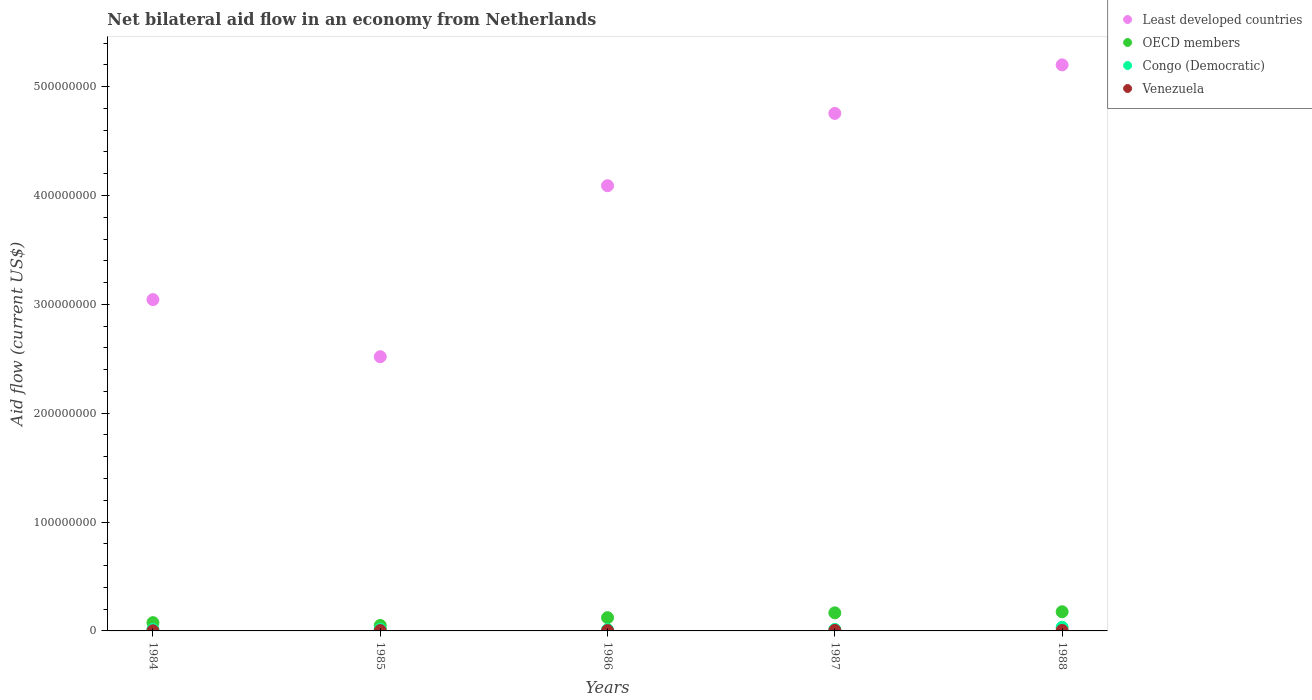How many different coloured dotlines are there?
Offer a very short reply. 4. What is the net bilateral aid flow in OECD members in 1988?
Provide a short and direct response. 1.76e+07. Across all years, what is the maximum net bilateral aid flow in OECD members?
Provide a short and direct response. 1.76e+07. In which year was the net bilateral aid flow in Venezuela minimum?
Your response must be concise. 1984. What is the total net bilateral aid flow in Least developed countries in the graph?
Your answer should be compact. 1.96e+09. What is the difference between the net bilateral aid flow in Venezuela in 1987 and that in 1988?
Keep it short and to the point. 8.00e+04. What is the difference between the net bilateral aid flow in OECD members in 1986 and the net bilateral aid flow in Congo (Democratic) in 1987?
Offer a very short reply. 1.08e+07. What is the average net bilateral aid flow in Congo (Democratic) per year?
Offer a very short reply. 1.81e+06. In the year 1987, what is the difference between the net bilateral aid flow in Least developed countries and net bilateral aid flow in Venezuela?
Give a very brief answer. 4.75e+08. What is the ratio of the net bilateral aid flow in Congo (Democratic) in 1986 to that in 1988?
Your answer should be very brief. 0.36. Is the difference between the net bilateral aid flow in Least developed countries in 1985 and 1986 greater than the difference between the net bilateral aid flow in Venezuela in 1985 and 1986?
Offer a terse response. No. What is the difference between the highest and the lowest net bilateral aid flow in Congo (Democratic)?
Your answer should be compact. 2.16e+06. In how many years, is the net bilateral aid flow in Least developed countries greater than the average net bilateral aid flow in Least developed countries taken over all years?
Make the answer very short. 3. Is the sum of the net bilateral aid flow in OECD members in 1985 and 1986 greater than the maximum net bilateral aid flow in Least developed countries across all years?
Offer a terse response. No. Is it the case that in every year, the sum of the net bilateral aid flow in Least developed countries and net bilateral aid flow in Congo (Democratic)  is greater than the sum of net bilateral aid flow in OECD members and net bilateral aid flow in Venezuela?
Your response must be concise. Yes. Is it the case that in every year, the sum of the net bilateral aid flow in Least developed countries and net bilateral aid flow in OECD members  is greater than the net bilateral aid flow in Congo (Democratic)?
Make the answer very short. Yes. Does the net bilateral aid flow in Least developed countries monotonically increase over the years?
Your answer should be compact. No. How many years are there in the graph?
Your answer should be compact. 5. Does the graph contain grids?
Make the answer very short. No. What is the title of the graph?
Make the answer very short. Net bilateral aid flow in an economy from Netherlands. Does "Madagascar" appear as one of the legend labels in the graph?
Provide a succinct answer. No. What is the label or title of the Y-axis?
Offer a terse response. Aid flow (current US$). What is the Aid flow (current US$) of Least developed countries in 1984?
Your answer should be very brief. 3.04e+08. What is the Aid flow (current US$) in OECD members in 1984?
Provide a succinct answer. 7.60e+06. What is the Aid flow (current US$) in Congo (Democratic) in 1984?
Your answer should be very brief. 1.43e+06. What is the Aid flow (current US$) in Least developed countries in 1985?
Give a very brief answer. 2.52e+08. What is the Aid flow (current US$) of OECD members in 1985?
Offer a very short reply. 5.03e+06. What is the Aid flow (current US$) in Congo (Democratic) in 1985?
Keep it short and to the point. 1.69e+06. What is the Aid flow (current US$) of Venezuela in 1985?
Provide a succinct answer. 3.20e+05. What is the Aid flow (current US$) of Least developed countries in 1986?
Give a very brief answer. 4.09e+08. What is the Aid flow (current US$) of OECD members in 1986?
Give a very brief answer. 1.22e+07. What is the Aid flow (current US$) in Congo (Democratic) in 1986?
Your answer should be very brief. 1.19e+06. What is the Aid flow (current US$) of Least developed countries in 1987?
Your answer should be very brief. 4.75e+08. What is the Aid flow (current US$) in OECD members in 1987?
Offer a very short reply. 1.66e+07. What is the Aid flow (current US$) in Congo (Democratic) in 1987?
Provide a short and direct response. 1.37e+06. What is the Aid flow (current US$) in Least developed countries in 1988?
Ensure brevity in your answer.  5.20e+08. What is the Aid flow (current US$) of OECD members in 1988?
Give a very brief answer. 1.76e+07. What is the Aid flow (current US$) in Congo (Democratic) in 1988?
Ensure brevity in your answer.  3.35e+06. Across all years, what is the maximum Aid flow (current US$) of Least developed countries?
Offer a very short reply. 5.20e+08. Across all years, what is the maximum Aid flow (current US$) in OECD members?
Give a very brief answer. 1.76e+07. Across all years, what is the maximum Aid flow (current US$) in Congo (Democratic)?
Offer a very short reply. 3.35e+06. Across all years, what is the minimum Aid flow (current US$) of Least developed countries?
Give a very brief answer. 2.52e+08. Across all years, what is the minimum Aid flow (current US$) in OECD members?
Your response must be concise. 5.03e+06. Across all years, what is the minimum Aid flow (current US$) of Congo (Democratic)?
Offer a very short reply. 1.19e+06. Across all years, what is the minimum Aid flow (current US$) in Venezuela?
Keep it short and to the point. 1.10e+05. What is the total Aid flow (current US$) of Least developed countries in the graph?
Your answer should be very brief. 1.96e+09. What is the total Aid flow (current US$) in OECD members in the graph?
Your response must be concise. 5.90e+07. What is the total Aid flow (current US$) of Congo (Democratic) in the graph?
Your answer should be compact. 9.03e+06. What is the total Aid flow (current US$) in Venezuela in the graph?
Make the answer very short. 1.61e+06. What is the difference between the Aid flow (current US$) in Least developed countries in 1984 and that in 1985?
Ensure brevity in your answer.  5.25e+07. What is the difference between the Aid flow (current US$) in OECD members in 1984 and that in 1985?
Ensure brevity in your answer.  2.57e+06. What is the difference between the Aid flow (current US$) of Least developed countries in 1984 and that in 1986?
Give a very brief answer. -1.05e+08. What is the difference between the Aid flow (current US$) in OECD members in 1984 and that in 1986?
Provide a short and direct response. -4.58e+06. What is the difference between the Aid flow (current US$) in Congo (Democratic) in 1984 and that in 1986?
Give a very brief answer. 2.40e+05. What is the difference between the Aid flow (current US$) in Least developed countries in 1984 and that in 1987?
Offer a terse response. -1.71e+08. What is the difference between the Aid flow (current US$) of OECD members in 1984 and that in 1987?
Your response must be concise. -9.02e+06. What is the difference between the Aid flow (current US$) of Venezuela in 1984 and that in 1987?
Give a very brief answer. -3.60e+05. What is the difference between the Aid flow (current US$) in Least developed countries in 1984 and that in 1988?
Offer a terse response. -2.16e+08. What is the difference between the Aid flow (current US$) in OECD members in 1984 and that in 1988?
Your answer should be very brief. -1.00e+07. What is the difference between the Aid flow (current US$) of Congo (Democratic) in 1984 and that in 1988?
Provide a short and direct response. -1.92e+06. What is the difference between the Aid flow (current US$) in Venezuela in 1984 and that in 1988?
Ensure brevity in your answer.  -2.80e+05. What is the difference between the Aid flow (current US$) of Least developed countries in 1985 and that in 1986?
Keep it short and to the point. -1.57e+08. What is the difference between the Aid flow (current US$) of OECD members in 1985 and that in 1986?
Ensure brevity in your answer.  -7.15e+06. What is the difference between the Aid flow (current US$) of Least developed countries in 1985 and that in 1987?
Offer a very short reply. -2.24e+08. What is the difference between the Aid flow (current US$) of OECD members in 1985 and that in 1987?
Ensure brevity in your answer.  -1.16e+07. What is the difference between the Aid flow (current US$) of Congo (Democratic) in 1985 and that in 1987?
Offer a terse response. 3.20e+05. What is the difference between the Aid flow (current US$) in Venezuela in 1985 and that in 1987?
Your response must be concise. -1.50e+05. What is the difference between the Aid flow (current US$) of Least developed countries in 1985 and that in 1988?
Your answer should be compact. -2.68e+08. What is the difference between the Aid flow (current US$) in OECD members in 1985 and that in 1988?
Keep it short and to the point. -1.26e+07. What is the difference between the Aid flow (current US$) of Congo (Democratic) in 1985 and that in 1988?
Your answer should be very brief. -1.66e+06. What is the difference between the Aid flow (current US$) of Venezuela in 1985 and that in 1988?
Offer a very short reply. -7.00e+04. What is the difference between the Aid flow (current US$) in Least developed countries in 1986 and that in 1987?
Your response must be concise. -6.64e+07. What is the difference between the Aid flow (current US$) in OECD members in 1986 and that in 1987?
Provide a short and direct response. -4.44e+06. What is the difference between the Aid flow (current US$) of Congo (Democratic) in 1986 and that in 1987?
Your answer should be compact. -1.80e+05. What is the difference between the Aid flow (current US$) in Venezuela in 1986 and that in 1987?
Provide a short and direct response. -1.50e+05. What is the difference between the Aid flow (current US$) in Least developed countries in 1986 and that in 1988?
Provide a short and direct response. -1.11e+08. What is the difference between the Aid flow (current US$) in OECD members in 1986 and that in 1988?
Ensure brevity in your answer.  -5.43e+06. What is the difference between the Aid flow (current US$) in Congo (Democratic) in 1986 and that in 1988?
Your answer should be compact. -2.16e+06. What is the difference between the Aid flow (current US$) in Venezuela in 1986 and that in 1988?
Keep it short and to the point. -7.00e+04. What is the difference between the Aid flow (current US$) in Least developed countries in 1987 and that in 1988?
Offer a terse response. -4.46e+07. What is the difference between the Aid flow (current US$) in OECD members in 1987 and that in 1988?
Ensure brevity in your answer.  -9.90e+05. What is the difference between the Aid flow (current US$) of Congo (Democratic) in 1987 and that in 1988?
Your answer should be very brief. -1.98e+06. What is the difference between the Aid flow (current US$) of Least developed countries in 1984 and the Aid flow (current US$) of OECD members in 1985?
Make the answer very short. 2.99e+08. What is the difference between the Aid flow (current US$) of Least developed countries in 1984 and the Aid flow (current US$) of Congo (Democratic) in 1985?
Provide a succinct answer. 3.03e+08. What is the difference between the Aid flow (current US$) of Least developed countries in 1984 and the Aid flow (current US$) of Venezuela in 1985?
Offer a very short reply. 3.04e+08. What is the difference between the Aid flow (current US$) in OECD members in 1984 and the Aid flow (current US$) in Congo (Democratic) in 1985?
Your answer should be compact. 5.91e+06. What is the difference between the Aid flow (current US$) of OECD members in 1984 and the Aid flow (current US$) of Venezuela in 1985?
Your response must be concise. 7.28e+06. What is the difference between the Aid flow (current US$) in Congo (Democratic) in 1984 and the Aid flow (current US$) in Venezuela in 1985?
Keep it short and to the point. 1.11e+06. What is the difference between the Aid flow (current US$) in Least developed countries in 1984 and the Aid flow (current US$) in OECD members in 1986?
Your response must be concise. 2.92e+08. What is the difference between the Aid flow (current US$) in Least developed countries in 1984 and the Aid flow (current US$) in Congo (Democratic) in 1986?
Make the answer very short. 3.03e+08. What is the difference between the Aid flow (current US$) of Least developed countries in 1984 and the Aid flow (current US$) of Venezuela in 1986?
Offer a terse response. 3.04e+08. What is the difference between the Aid flow (current US$) in OECD members in 1984 and the Aid flow (current US$) in Congo (Democratic) in 1986?
Provide a succinct answer. 6.41e+06. What is the difference between the Aid flow (current US$) in OECD members in 1984 and the Aid flow (current US$) in Venezuela in 1986?
Offer a very short reply. 7.28e+06. What is the difference between the Aid flow (current US$) in Congo (Democratic) in 1984 and the Aid flow (current US$) in Venezuela in 1986?
Provide a short and direct response. 1.11e+06. What is the difference between the Aid flow (current US$) of Least developed countries in 1984 and the Aid flow (current US$) of OECD members in 1987?
Give a very brief answer. 2.88e+08. What is the difference between the Aid flow (current US$) of Least developed countries in 1984 and the Aid flow (current US$) of Congo (Democratic) in 1987?
Offer a very short reply. 3.03e+08. What is the difference between the Aid flow (current US$) of Least developed countries in 1984 and the Aid flow (current US$) of Venezuela in 1987?
Provide a succinct answer. 3.04e+08. What is the difference between the Aid flow (current US$) in OECD members in 1984 and the Aid flow (current US$) in Congo (Democratic) in 1987?
Offer a very short reply. 6.23e+06. What is the difference between the Aid flow (current US$) of OECD members in 1984 and the Aid flow (current US$) of Venezuela in 1987?
Your response must be concise. 7.13e+06. What is the difference between the Aid flow (current US$) in Congo (Democratic) in 1984 and the Aid flow (current US$) in Venezuela in 1987?
Keep it short and to the point. 9.60e+05. What is the difference between the Aid flow (current US$) in Least developed countries in 1984 and the Aid flow (current US$) in OECD members in 1988?
Provide a succinct answer. 2.87e+08. What is the difference between the Aid flow (current US$) of Least developed countries in 1984 and the Aid flow (current US$) of Congo (Democratic) in 1988?
Make the answer very short. 3.01e+08. What is the difference between the Aid flow (current US$) of Least developed countries in 1984 and the Aid flow (current US$) of Venezuela in 1988?
Offer a terse response. 3.04e+08. What is the difference between the Aid flow (current US$) of OECD members in 1984 and the Aid flow (current US$) of Congo (Democratic) in 1988?
Ensure brevity in your answer.  4.25e+06. What is the difference between the Aid flow (current US$) of OECD members in 1984 and the Aid flow (current US$) of Venezuela in 1988?
Provide a short and direct response. 7.21e+06. What is the difference between the Aid flow (current US$) in Congo (Democratic) in 1984 and the Aid flow (current US$) in Venezuela in 1988?
Offer a terse response. 1.04e+06. What is the difference between the Aid flow (current US$) of Least developed countries in 1985 and the Aid flow (current US$) of OECD members in 1986?
Your answer should be compact. 2.40e+08. What is the difference between the Aid flow (current US$) in Least developed countries in 1985 and the Aid flow (current US$) in Congo (Democratic) in 1986?
Ensure brevity in your answer.  2.51e+08. What is the difference between the Aid flow (current US$) of Least developed countries in 1985 and the Aid flow (current US$) of Venezuela in 1986?
Keep it short and to the point. 2.52e+08. What is the difference between the Aid flow (current US$) of OECD members in 1985 and the Aid flow (current US$) of Congo (Democratic) in 1986?
Your response must be concise. 3.84e+06. What is the difference between the Aid flow (current US$) in OECD members in 1985 and the Aid flow (current US$) in Venezuela in 1986?
Ensure brevity in your answer.  4.71e+06. What is the difference between the Aid flow (current US$) in Congo (Democratic) in 1985 and the Aid flow (current US$) in Venezuela in 1986?
Offer a very short reply. 1.37e+06. What is the difference between the Aid flow (current US$) of Least developed countries in 1985 and the Aid flow (current US$) of OECD members in 1987?
Your response must be concise. 2.35e+08. What is the difference between the Aid flow (current US$) of Least developed countries in 1985 and the Aid flow (current US$) of Congo (Democratic) in 1987?
Provide a short and direct response. 2.51e+08. What is the difference between the Aid flow (current US$) of Least developed countries in 1985 and the Aid flow (current US$) of Venezuela in 1987?
Keep it short and to the point. 2.51e+08. What is the difference between the Aid flow (current US$) in OECD members in 1985 and the Aid flow (current US$) in Congo (Democratic) in 1987?
Ensure brevity in your answer.  3.66e+06. What is the difference between the Aid flow (current US$) of OECD members in 1985 and the Aid flow (current US$) of Venezuela in 1987?
Provide a short and direct response. 4.56e+06. What is the difference between the Aid flow (current US$) in Congo (Democratic) in 1985 and the Aid flow (current US$) in Venezuela in 1987?
Provide a short and direct response. 1.22e+06. What is the difference between the Aid flow (current US$) of Least developed countries in 1985 and the Aid flow (current US$) of OECD members in 1988?
Keep it short and to the point. 2.34e+08. What is the difference between the Aid flow (current US$) in Least developed countries in 1985 and the Aid flow (current US$) in Congo (Democratic) in 1988?
Your answer should be very brief. 2.49e+08. What is the difference between the Aid flow (current US$) of Least developed countries in 1985 and the Aid flow (current US$) of Venezuela in 1988?
Your answer should be compact. 2.52e+08. What is the difference between the Aid flow (current US$) of OECD members in 1985 and the Aid flow (current US$) of Congo (Democratic) in 1988?
Offer a very short reply. 1.68e+06. What is the difference between the Aid flow (current US$) in OECD members in 1985 and the Aid flow (current US$) in Venezuela in 1988?
Your answer should be compact. 4.64e+06. What is the difference between the Aid flow (current US$) in Congo (Democratic) in 1985 and the Aid flow (current US$) in Venezuela in 1988?
Your response must be concise. 1.30e+06. What is the difference between the Aid flow (current US$) of Least developed countries in 1986 and the Aid flow (current US$) of OECD members in 1987?
Give a very brief answer. 3.92e+08. What is the difference between the Aid flow (current US$) of Least developed countries in 1986 and the Aid flow (current US$) of Congo (Democratic) in 1987?
Your answer should be very brief. 4.08e+08. What is the difference between the Aid flow (current US$) of Least developed countries in 1986 and the Aid flow (current US$) of Venezuela in 1987?
Offer a very short reply. 4.09e+08. What is the difference between the Aid flow (current US$) in OECD members in 1986 and the Aid flow (current US$) in Congo (Democratic) in 1987?
Your answer should be very brief. 1.08e+07. What is the difference between the Aid flow (current US$) in OECD members in 1986 and the Aid flow (current US$) in Venezuela in 1987?
Give a very brief answer. 1.17e+07. What is the difference between the Aid flow (current US$) of Congo (Democratic) in 1986 and the Aid flow (current US$) of Venezuela in 1987?
Ensure brevity in your answer.  7.20e+05. What is the difference between the Aid flow (current US$) in Least developed countries in 1986 and the Aid flow (current US$) in OECD members in 1988?
Ensure brevity in your answer.  3.91e+08. What is the difference between the Aid flow (current US$) of Least developed countries in 1986 and the Aid flow (current US$) of Congo (Democratic) in 1988?
Offer a very short reply. 4.06e+08. What is the difference between the Aid flow (current US$) of Least developed countries in 1986 and the Aid flow (current US$) of Venezuela in 1988?
Your response must be concise. 4.09e+08. What is the difference between the Aid flow (current US$) of OECD members in 1986 and the Aid flow (current US$) of Congo (Democratic) in 1988?
Provide a short and direct response. 8.83e+06. What is the difference between the Aid flow (current US$) in OECD members in 1986 and the Aid flow (current US$) in Venezuela in 1988?
Your answer should be very brief. 1.18e+07. What is the difference between the Aid flow (current US$) in Congo (Democratic) in 1986 and the Aid flow (current US$) in Venezuela in 1988?
Your response must be concise. 8.00e+05. What is the difference between the Aid flow (current US$) in Least developed countries in 1987 and the Aid flow (current US$) in OECD members in 1988?
Your answer should be very brief. 4.58e+08. What is the difference between the Aid flow (current US$) of Least developed countries in 1987 and the Aid flow (current US$) of Congo (Democratic) in 1988?
Your response must be concise. 4.72e+08. What is the difference between the Aid flow (current US$) in Least developed countries in 1987 and the Aid flow (current US$) in Venezuela in 1988?
Give a very brief answer. 4.75e+08. What is the difference between the Aid flow (current US$) of OECD members in 1987 and the Aid flow (current US$) of Congo (Democratic) in 1988?
Provide a succinct answer. 1.33e+07. What is the difference between the Aid flow (current US$) of OECD members in 1987 and the Aid flow (current US$) of Venezuela in 1988?
Offer a terse response. 1.62e+07. What is the difference between the Aid flow (current US$) of Congo (Democratic) in 1987 and the Aid flow (current US$) of Venezuela in 1988?
Make the answer very short. 9.80e+05. What is the average Aid flow (current US$) of Least developed countries per year?
Make the answer very short. 3.92e+08. What is the average Aid flow (current US$) of OECD members per year?
Provide a short and direct response. 1.18e+07. What is the average Aid flow (current US$) in Congo (Democratic) per year?
Make the answer very short. 1.81e+06. What is the average Aid flow (current US$) of Venezuela per year?
Make the answer very short. 3.22e+05. In the year 1984, what is the difference between the Aid flow (current US$) of Least developed countries and Aid flow (current US$) of OECD members?
Provide a short and direct response. 2.97e+08. In the year 1984, what is the difference between the Aid flow (current US$) in Least developed countries and Aid flow (current US$) in Congo (Democratic)?
Provide a succinct answer. 3.03e+08. In the year 1984, what is the difference between the Aid flow (current US$) of Least developed countries and Aid flow (current US$) of Venezuela?
Provide a succinct answer. 3.04e+08. In the year 1984, what is the difference between the Aid flow (current US$) of OECD members and Aid flow (current US$) of Congo (Democratic)?
Your answer should be very brief. 6.17e+06. In the year 1984, what is the difference between the Aid flow (current US$) of OECD members and Aid flow (current US$) of Venezuela?
Your answer should be compact. 7.49e+06. In the year 1984, what is the difference between the Aid flow (current US$) in Congo (Democratic) and Aid flow (current US$) in Venezuela?
Keep it short and to the point. 1.32e+06. In the year 1985, what is the difference between the Aid flow (current US$) in Least developed countries and Aid flow (current US$) in OECD members?
Your response must be concise. 2.47e+08. In the year 1985, what is the difference between the Aid flow (current US$) of Least developed countries and Aid flow (current US$) of Congo (Democratic)?
Provide a short and direct response. 2.50e+08. In the year 1985, what is the difference between the Aid flow (current US$) in Least developed countries and Aid flow (current US$) in Venezuela?
Your answer should be very brief. 2.52e+08. In the year 1985, what is the difference between the Aid flow (current US$) in OECD members and Aid flow (current US$) in Congo (Democratic)?
Give a very brief answer. 3.34e+06. In the year 1985, what is the difference between the Aid flow (current US$) of OECD members and Aid flow (current US$) of Venezuela?
Your response must be concise. 4.71e+06. In the year 1985, what is the difference between the Aid flow (current US$) in Congo (Democratic) and Aid flow (current US$) in Venezuela?
Your answer should be very brief. 1.37e+06. In the year 1986, what is the difference between the Aid flow (current US$) of Least developed countries and Aid flow (current US$) of OECD members?
Provide a succinct answer. 3.97e+08. In the year 1986, what is the difference between the Aid flow (current US$) of Least developed countries and Aid flow (current US$) of Congo (Democratic)?
Keep it short and to the point. 4.08e+08. In the year 1986, what is the difference between the Aid flow (current US$) in Least developed countries and Aid flow (current US$) in Venezuela?
Ensure brevity in your answer.  4.09e+08. In the year 1986, what is the difference between the Aid flow (current US$) in OECD members and Aid flow (current US$) in Congo (Democratic)?
Give a very brief answer. 1.10e+07. In the year 1986, what is the difference between the Aid flow (current US$) of OECD members and Aid flow (current US$) of Venezuela?
Keep it short and to the point. 1.19e+07. In the year 1986, what is the difference between the Aid flow (current US$) in Congo (Democratic) and Aid flow (current US$) in Venezuela?
Provide a succinct answer. 8.70e+05. In the year 1987, what is the difference between the Aid flow (current US$) of Least developed countries and Aid flow (current US$) of OECD members?
Your response must be concise. 4.59e+08. In the year 1987, what is the difference between the Aid flow (current US$) in Least developed countries and Aid flow (current US$) in Congo (Democratic)?
Ensure brevity in your answer.  4.74e+08. In the year 1987, what is the difference between the Aid flow (current US$) in Least developed countries and Aid flow (current US$) in Venezuela?
Provide a short and direct response. 4.75e+08. In the year 1987, what is the difference between the Aid flow (current US$) in OECD members and Aid flow (current US$) in Congo (Democratic)?
Keep it short and to the point. 1.52e+07. In the year 1987, what is the difference between the Aid flow (current US$) in OECD members and Aid flow (current US$) in Venezuela?
Offer a very short reply. 1.62e+07. In the year 1987, what is the difference between the Aid flow (current US$) of Congo (Democratic) and Aid flow (current US$) of Venezuela?
Ensure brevity in your answer.  9.00e+05. In the year 1988, what is the difference between the Aid flow (current US$) of Least developed countries and Aid flow (current US$) of OECD members?
Provide a short and direct response. 5.02e+08. In the year 1988, what is the difference between the Aid flow (current US$) of Least developed countries and Aid flow (current US$) of Congo (Democratic)?
Your response must be concise. 5.17e+08. In the year 1988, what is the difference between the Aid flow (current US$) in Least developed countries and Aid flow (current US$) in Venezuela?
Give a very brief answer. 5.20e+08. In the year 1988, what is the difference between the Aid flow (current US$) of OECD members and Aid flow (current US$) of Congo (Democratic)?
Keep it short and to the point. 1.43e+07. In the year 1988, what is the difference between the Aid flow (current US$) of OECD members and Aid flow (current US$) of Venezuela?
Ensure brevity in your answer.  1.72e+07. In the year 1988, what is the difference between the Aid flow (current US$) of Congo (Democratic) and Aid flow (current US$) of Venezuela?
Make the answer very short. 2.96e+06. What is the ratio of the Aid flow (current US$) in Least developed countries in 1984 to that in 1985?
Offer a terse response. 1.21. What is the ratio of the Aid flow (current US$) of OECD members in 1984 to that in 1985?
Keep it short and to the point. 1.51. What is the ratio of the Aid flow (current US$) in Congo (Democratic) in 1984 to that in 1985?
Provide a succinct answer. 0.85. What is the ratio of the Aid flow (current US$) of Venezuela in 1984 to that in 1985?
Make the answer very short. 0.34. What is the ratio of the Aid flow (current US$) of Least developed countries in 1984 to that in 1986?
Offer a very short reply. 0.74. What is the ratio of the Aid flow (current US$) in OECD members in 1984 to that in 1986?
Make the answer very short. 0.62. What is the ratio of the Aid flow (current US$) in Congo (Democratic) in 1984 to that in 1986?
Provide a short and direct response. 1.2. What is the ratio of the Aid flow (current US$) in Venezuela in 1984 to that in 1986?
Keep it short and to the point. 0.34. What is the ratio of the Aid flow (current US$) of Least developed countries in 1984 to that in 1987?
Keep it short and to the point. 0.64. What is the ratio of the Aid flow (current US$) of OECD members in 1984 to that in 1987?
Provide a short and direct response. 0.46. What is the ratio of the Aid flow (current US$) of Congo (Democratic) in 1984 to that in 1987?
Ensure brevity in your answer.  1.04. What is the ratio of the Aid flow (current US$) of Venezuela in 1984 to that in 1987?
Your answer should be compact. 0.23. What is the ratio of the Aid flow (current US$) in Least developed countries in 1984 to that in 1988?
Provide a short and direct response. 0.59. What is the ratio of the Aid flow (current US$) in OECD members in 1984 to that in 1988?
Offer a very short reply. 0.43. What is the ratio of the Aid flow (current US$) in Congo (Democratic) in 1984 to that in 1988?
Offer a very short reply. 0.43. What is the ratio of the Aid flow (current US$) in Venezuela in 1984 to that in 1988?
Keep it short and to the point. 0.28. What is the ratio of the Aid flow (current US$) in Least developed countries in 1985 to that in 1986?
Your answer should be compact. 0.62. What is the ratio of the Aid flow (current US$) in OECD members in 1985 to that in 1986?
Ensure brevity in your answer.  0.41. What is the ratio of the Aid flow (current US$) in Congo (Democratic) in 1985 to that in 1986?
Give a very brief answer. 1.42. What is the ratio of the Aid flow (current US$) in Venezuela in 1985 to that in 1986?
Keep it short and to the point. 1. What is the ratio of the Aid flow (current US$) in Least developed countries in 1985 to that in 1987?
Your answer should be very brief. 0.53. What is the ratio of the Aid flow (current US$) of OECD members in 1985 to that in 1987?
Provide a succinct answer. 0.3. What is the ratio of the Aid flow (current US$) of Congo (Democratic) in 1985 to that in 1987?
Your response must be concise. 1.23. What is the ratio of the Aid flow (current US$) in Venezuela in 1985 to that in 1987?
Provide a succinct answer. 0.68. What is the ratio of the Aid flow (current US$) of Least developed countries in 1985 to that in 1988?
Your response must be concise. 0.48. What is the ratio of the Aid flow (current US$) in OECD members in 1985 to that in 1988?
Offer a terse response. 0.29. What is the ratio of the Aid flow (current US$) in Congo (Democratic) in 1985 to that in 1988?
Give a very brief answer. 0.5. What is the ratio of the Aid flow (current US$) in Venezuela in 1985 to that in 1988?
Offer a very short reply. 0.82. What is the ratio of the Aid flow (current US$) of Least developed countries in 1986 to that in 1987?
Your response must be concise. 0.86. What is the ratio of the Aid flow (current US$) of OECD members in 1986 to that in 1987?
Your answer should be compact. 0.73. What is the ratio of the Aid flow (current US$) of Congo (Democratic) in 1986 to that in 1987?
Your answer should be compact. 0.87. What is the ratio of the Aid flow (current US$) in Venezuela in 1986 to that in 1987?
Your answer should be compact. 0.68. What is the ratio of the Aid flow (current US$) in Least developed countries in 1986 to that in 1988?
Offer a terse response. 0.79. What is the ratio of the Aid flow (current US$) of OECD members in 1986 to that in 1988?
Keep it short and to the point. 0.69. What is the ratio of the Aid flow (current US$) of Congo (Democratic) in 1986 to that in 1988?
Keep it short and to the point. 0.36. What is the ratio of the Aid flow (current US$) of Venezuela in 1986 to that in 1988?
Your answer should be very brief. 0.82. What is the ratio of the Aid flow (current US$) of Least developed countries in 1987 to that in 1988?
Provide a succinct answer. 0.91. What is the ratio of the Aid flow (current US$) of OECD members in 1987 to that in 1988?
Offer a very short reply. 0.94. What is the ratio of the Aid flow (current US$) of Congo (Democratic) in 1987 to that in 1988?
Give a very brief answer. 0.41. What is the ratio of the Aid flow (current US$) in Venezuela in 1987 to that in 1988?
Provide a succinct answer. 1.21. What is the difference between the highest and the second highest Aid flow (current US$) in Least developed countries?
Ensure brevity in your answer.  4.46e+07. What is the difference between the highest and the second highest Aid flow (current US$) in OECD members?
Offer a terse response. 9.90e+05. What is the difference between the highest and the second highest Aid flow (current US$) in Congo (Democratic)?
Offer a very short reply. 1.66e+06. What is the difference between the highest and the second highest Aid flow (current US$) in Venezuela?
Provide a short and direct response. 8.00e+04. What is the difference between the highest and the lowest Aid flow (current US$) of Least developed countries?
Keep it short and to the point. 2.68e+08. What is the difference between the highest and the lowest Aid flow (current US$) of OECD members?
Provide a short and direct response. 1.26e+07. What is the difference between the highest and the lowest Aid flow (current US$) in Congo (Democratic)?
Your answer should be compact. 2.16e+06. 